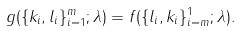<formula> <loc_0><loc_0><loc_500><loc_500>g ( \{ k _ { i } , l _ { i } \} _ { i = 1 } ^ { m } ; \lambda ) = f ( \{ l _ { i } , k _ { i } \} _ { i = m } ^ { 1 } ; \lambda ) .</formula> 